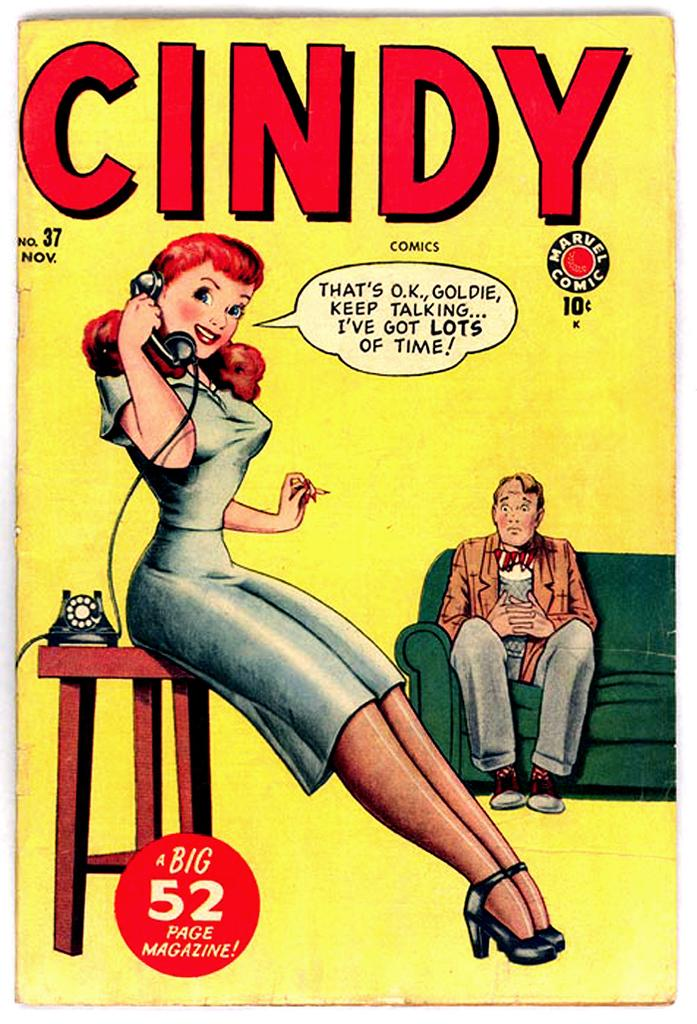What type of image is being described? The image is a poster. What is happening in the poster? There is a man sitting on a sofa and a woman sitting on a stool. The woman is talking on the phone. What can be seen in the poster besides the people? There is text written on the poster. What type of art is displayed on the wall behind the man in the poster? There is no art displayed on the wall behind the man in the poster. What season is depicted in the poster? The poster does not depict a specific season; it simply shows a man sitting on a sofa and a woman sitting on a stool. 